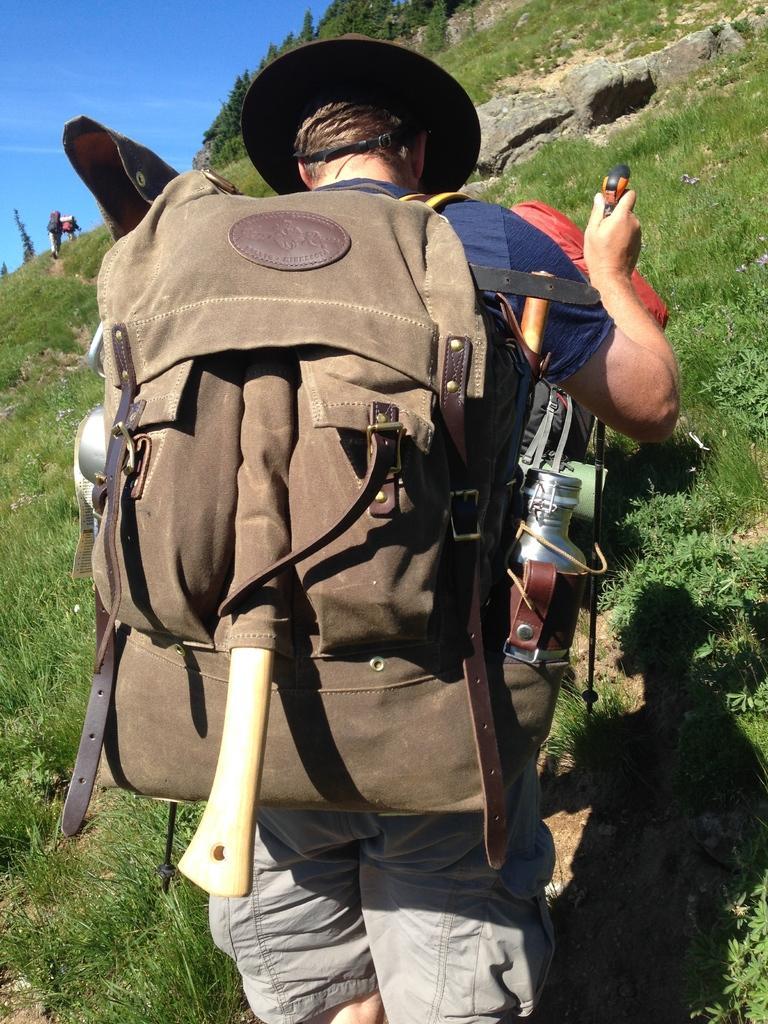Please provide a concise description of this image. In this image In the middle there is a man he wear blue t shirt, trouser and backpack. In the background there is a hill and sky. 